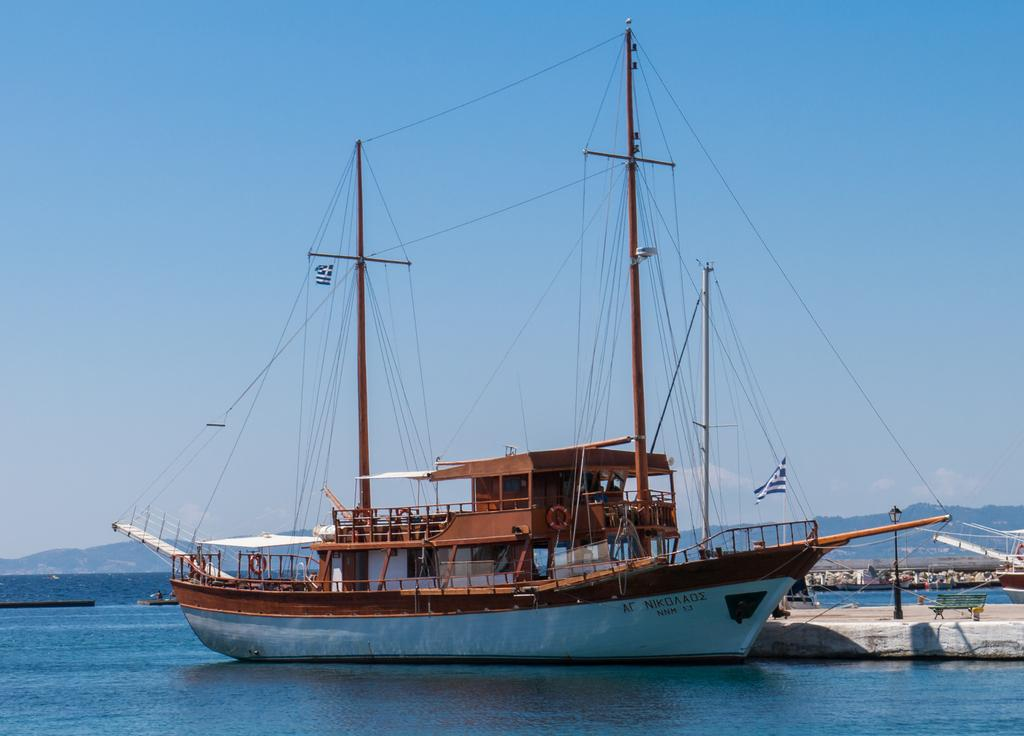What is the main subject of the image? The main subject of the image is ships. What type of environment are the ships in? The ships are in water, which is visible at the bottom of the image. Can you touch the vacation in the image? There is no vacation present in the image; it features ships in water. Where is the drawer located in the image? There is no drawer present in the image. 